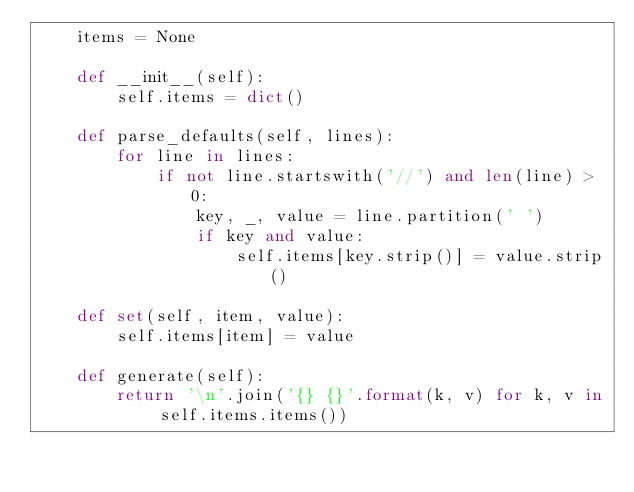<code> <loc_0><loc_0><loc_500><loc_500><_Python_>    items = None

    def __init__(self):
        self.items = dict()

    def parse_defaults(self, lines):
        for line in lines:
            if not line.startswith('//') and len(line) > 0:
                key, _, value = line.partition(' ')
                if key and value:
                    self.items[key.strip()] = value.strip()

    def set(self, item, value):
        self.items[item] = value

    def generate(self):
        return '\n'.join('{} {}'.format(k, v) for k, v in self.items.items())
</code> 